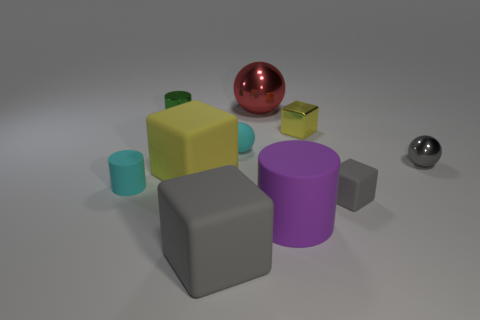Subtract 1 cubes. How many cubes are left? 3 Subtract all green cylinders. Subtract all yellow balls. How many cylinders are left? 2 Subtract all spheres. How many objects are left? 7 Add 4 tiny metal cubes. How many tiny metal cubes exist? 5 Subtract 0 purple balls. How many objects are left? 10 Subtract all green metallic things. Subtract all small metallic balls. How many objects are left? 8 Add 6 large purple rubber cylinders. How many large purple rubber cylinders are left? 7 